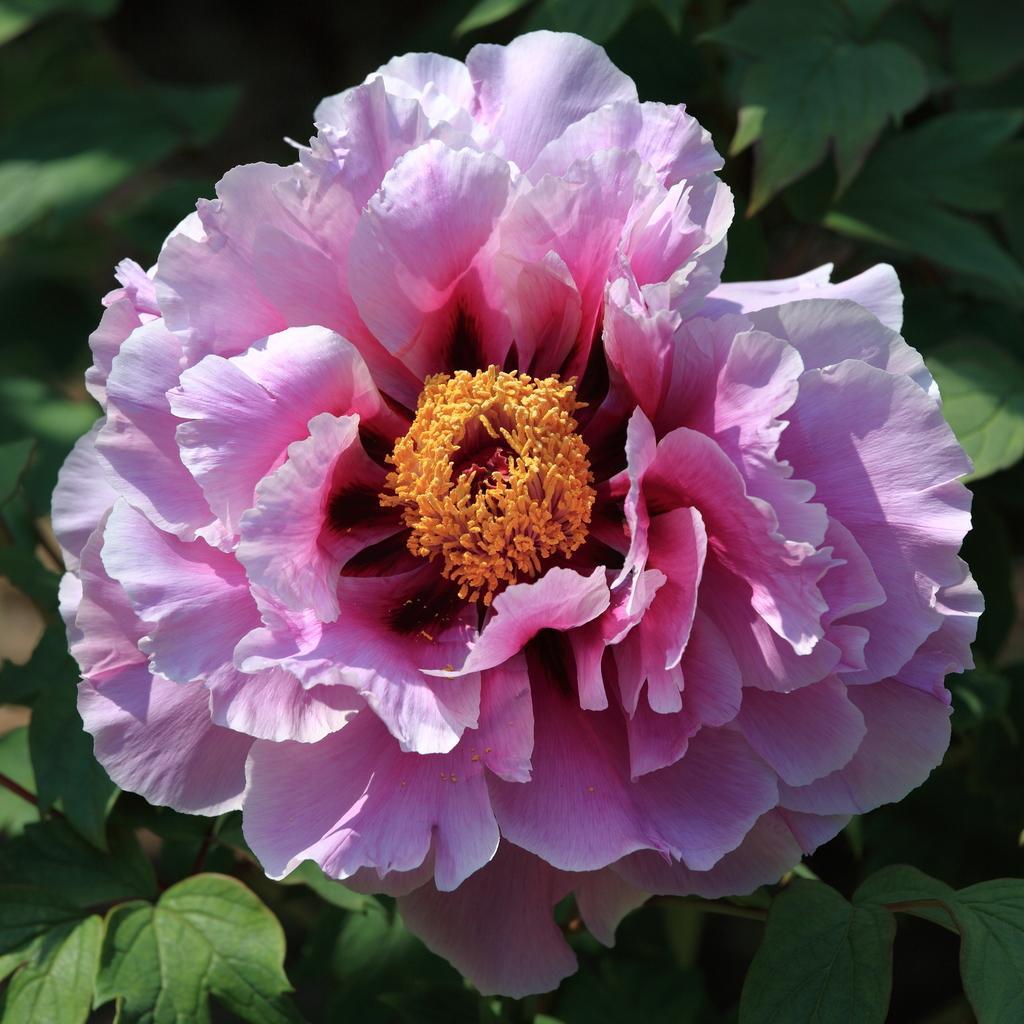Can you describe this image briefly? In this image we can see pink color flower. In the background, we can see leaves. 